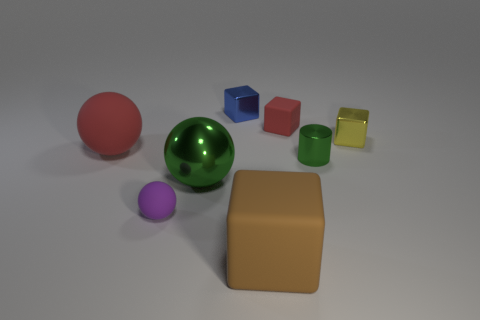What is the shape of the shiny thing that is the same color as the tiny shiny cylinder?
Your answer should be compact. Sphere. There is a matte cube that is behind the big rubber thing that is behind the green sphere; what is its size?
Make the answer very short. Small. What number of purple objects are cylinders or spheres?
Keep it short and to the point. 1. Are there fewer small metal cubes on the left side of the tiny purple thing than blocks in front of the small blue cube?
Provide a succinct answer. Yes. There is a yellow metallic cube; does it have the same size as the green shiny object that is on the left side of the blue metal object?
Your answer should be compact. No. What number of green metallic spheres are the same size as the purple ball?
Keep it short and to the point. 0. How many tiny things are either blue cubes or brown matte objects?
Provide a short and direct response. 1. Is there a large gray ball?
Your answer should be compact. No. Is the number of blue shiny objects that are behind the green sphere greater than the number of tiny yellow metal blocks in front of the large cube?
Your answer should be compact. Yes. There is a matte sphere that is in front of the big thing that is left of the purple matte thing; what color is it?
Offer a very short reply. Purple. 